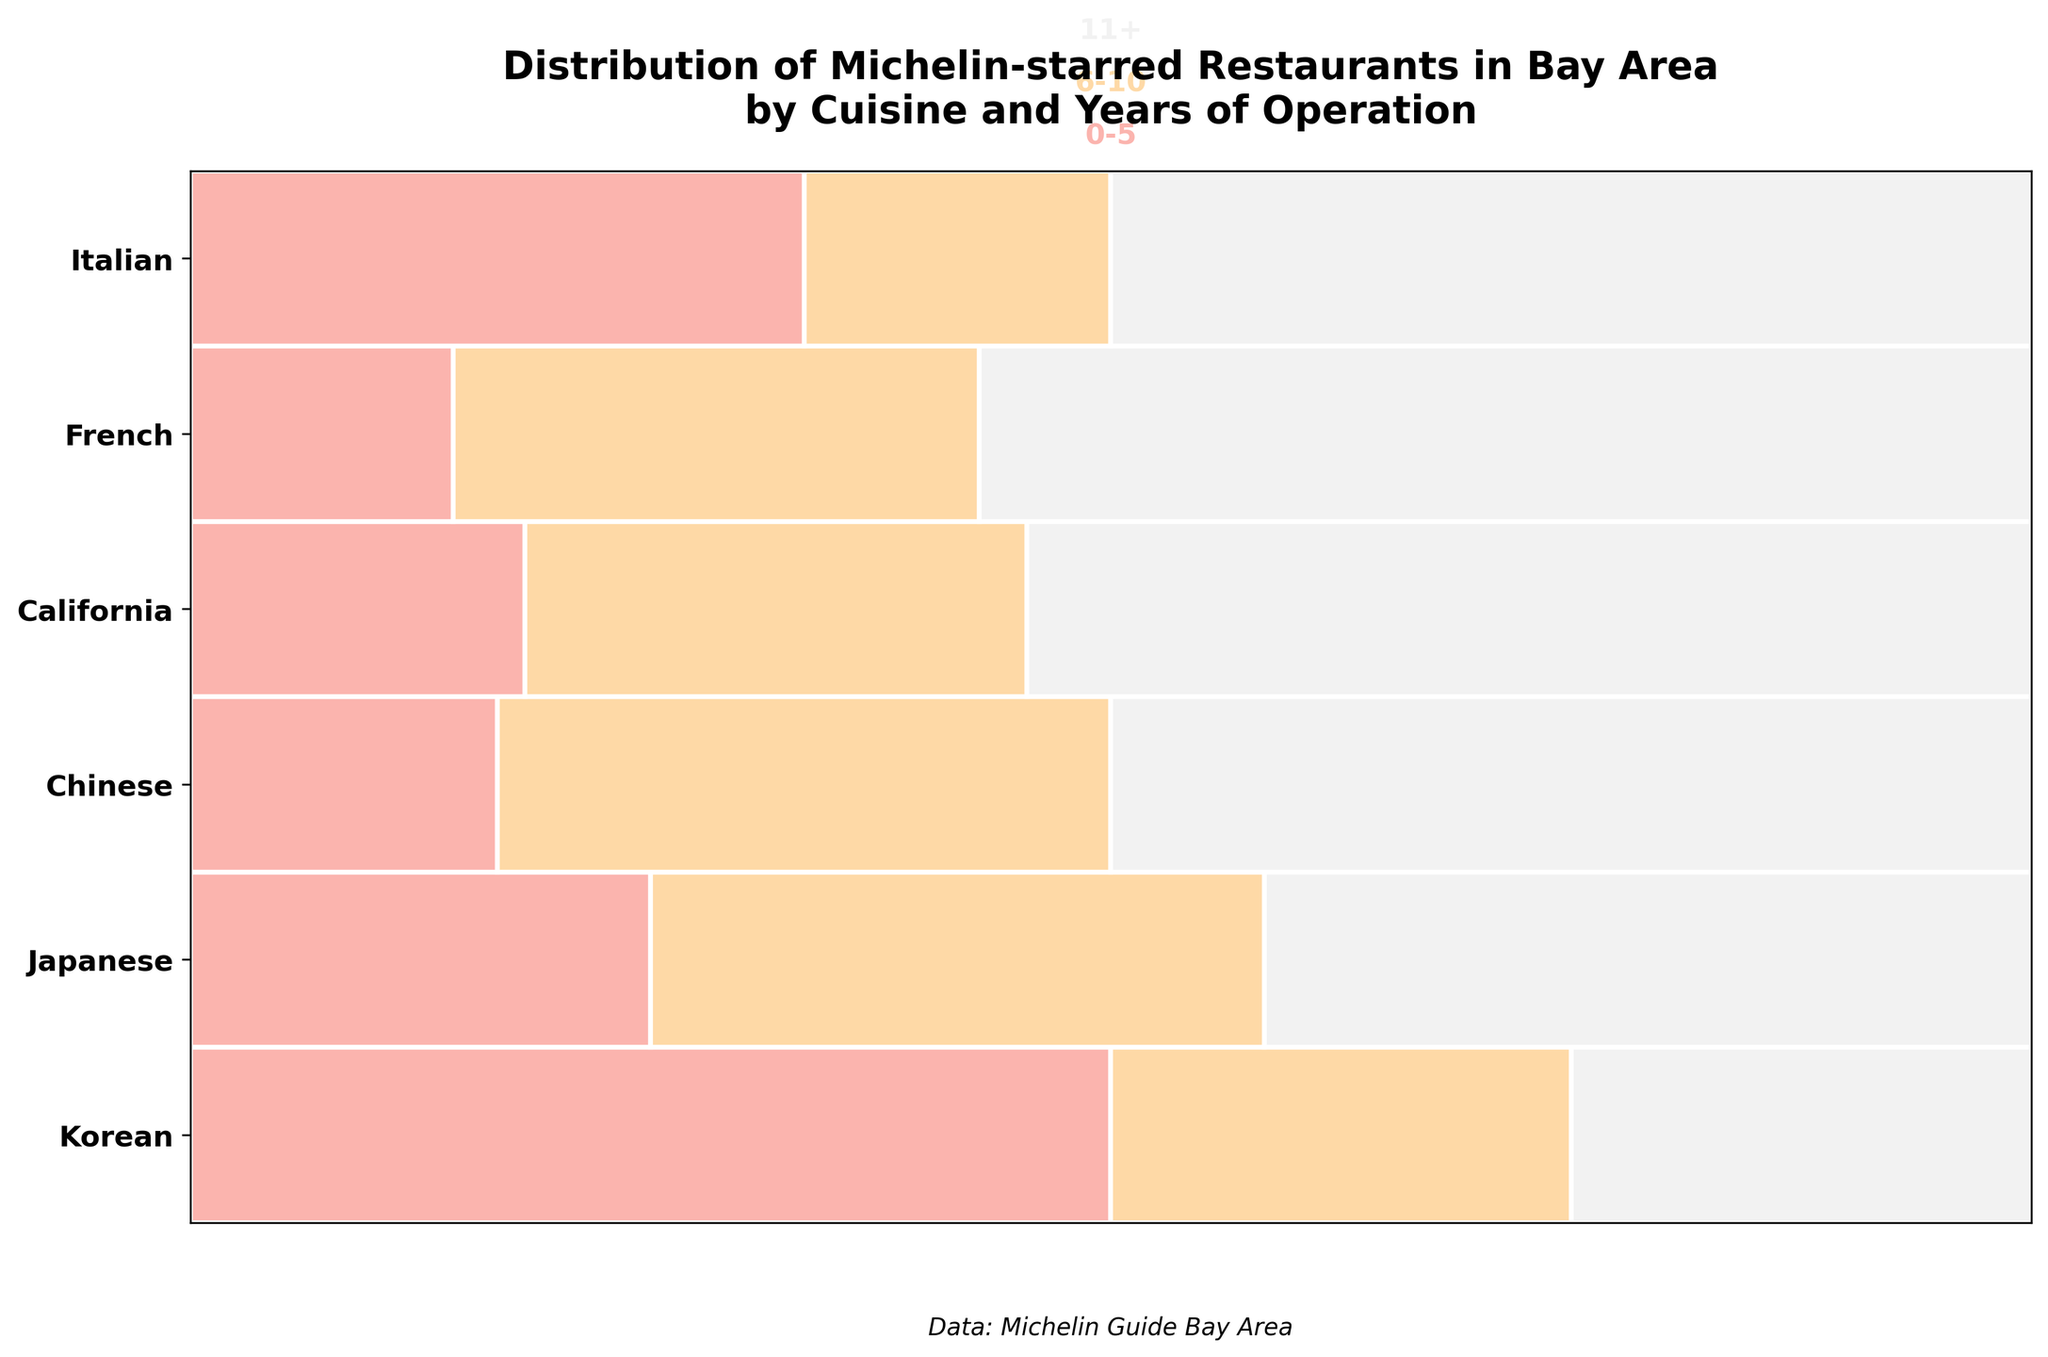what is the title of the plot? The title can be found at the top of the figure in bold and larger font size. It reads "Distribution of Michelin-starred Restaurants in Bay Area by Cuisine and Years of Operation".
Answer: Distribution of Michelin-starred Restaurants in Bay Area by Cuisine and Years of Operation How many cuisines are depicted in the plot? Count the unique labels on the y-axis which represent different cuisines. In this figure, the y-axis has the following labels: Korean, Japanese, Chinese, California, French, Italian.
Answer: 6 Which cuisine has the largest proportion of restaurants with 11+ years of operation? Look at the sections in each horizontal bar corresponding to the "11+" years of operation. The width of the section represents the proportion. California cuisine has the widest "11+" section in the plot.
Answer: California How many Michelin-starred Korean restaurants have been in operation for 6-10 years? Identify the Korean row and find the section labeled “6-10 years”. Each section corresponds to a number on the grid below. There is 1 section for 6-10 years.
Answer: 1 Which cuisine has the smallest proportion of restaurants in the 0-5 years of operation category? Compare the width of the rectangles within the "0-5" category for each cuisine. French cuisine has the narrowest section in the 0-5 years category.
Answer: French What is the combined count of Japanese and Chinese restaurants that have been in operation for over 11 years? Add the counts of Japanese and Chinese restaurants in the "11+" category. For Japanese, it's 5, and for Chinese, it is 3. So, the combined count is 5 + 3 = 8.
Answer: 8 Which cuisine has the most evenly distributed restaurants across all years of operation? Look to see which cuisine's row has the most similarly sized sections for each time range. California cuisine has relatively even-sized sections across all years of operation.
Answer: California Are there more Michelin-starred Japanese or French restaurants with 6-10 years of operation? Compare the segments in the "6-10 years" category for Japanese and French cuisines. Japanese has 4 restaurants, whereas French has 2. So, Japanese has more.
Answer: Japanese Which two cuisines have equal counts of restaurants in the 0-5 years of operation category? Compare the sections in the "0-5 years" category for each cuisine. Both Korean and California have 2 restaurants each in this specific category.
Answer: Korean and California 